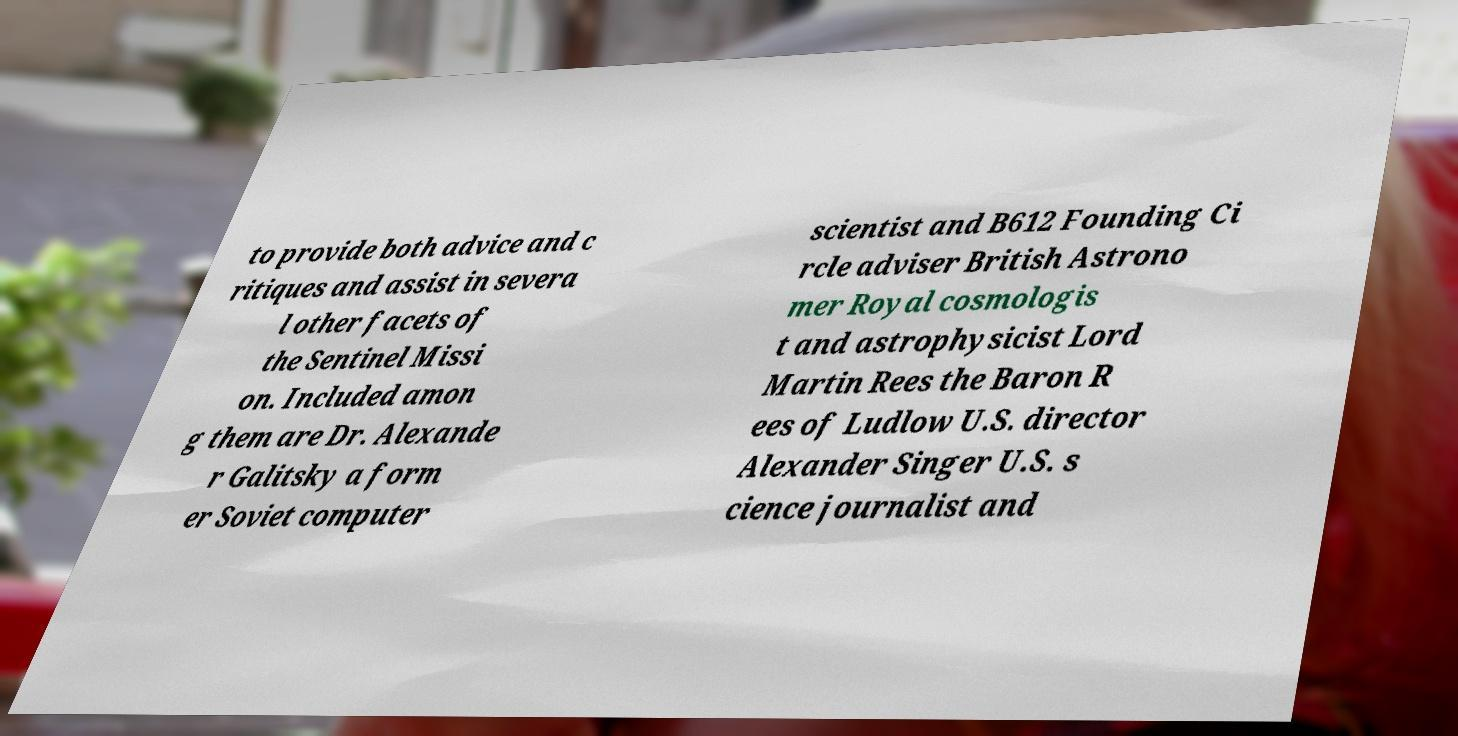Please read and relay the text visible in this image. What does it say? to provide both advice and c ritiques and assist in severa l other facets of the Sentinel Missi on. Included amon g them are Dr. Alexande r Galitsky a form er Soviet computer scientist and B612 Founding Ci rcle adviser British Astrono mer Royal cosmologis t and astrophysicist Lord Martin Rees the Baron R ees of Ludlow U.S. director Alexander Singer U.S. s cience journalist and 